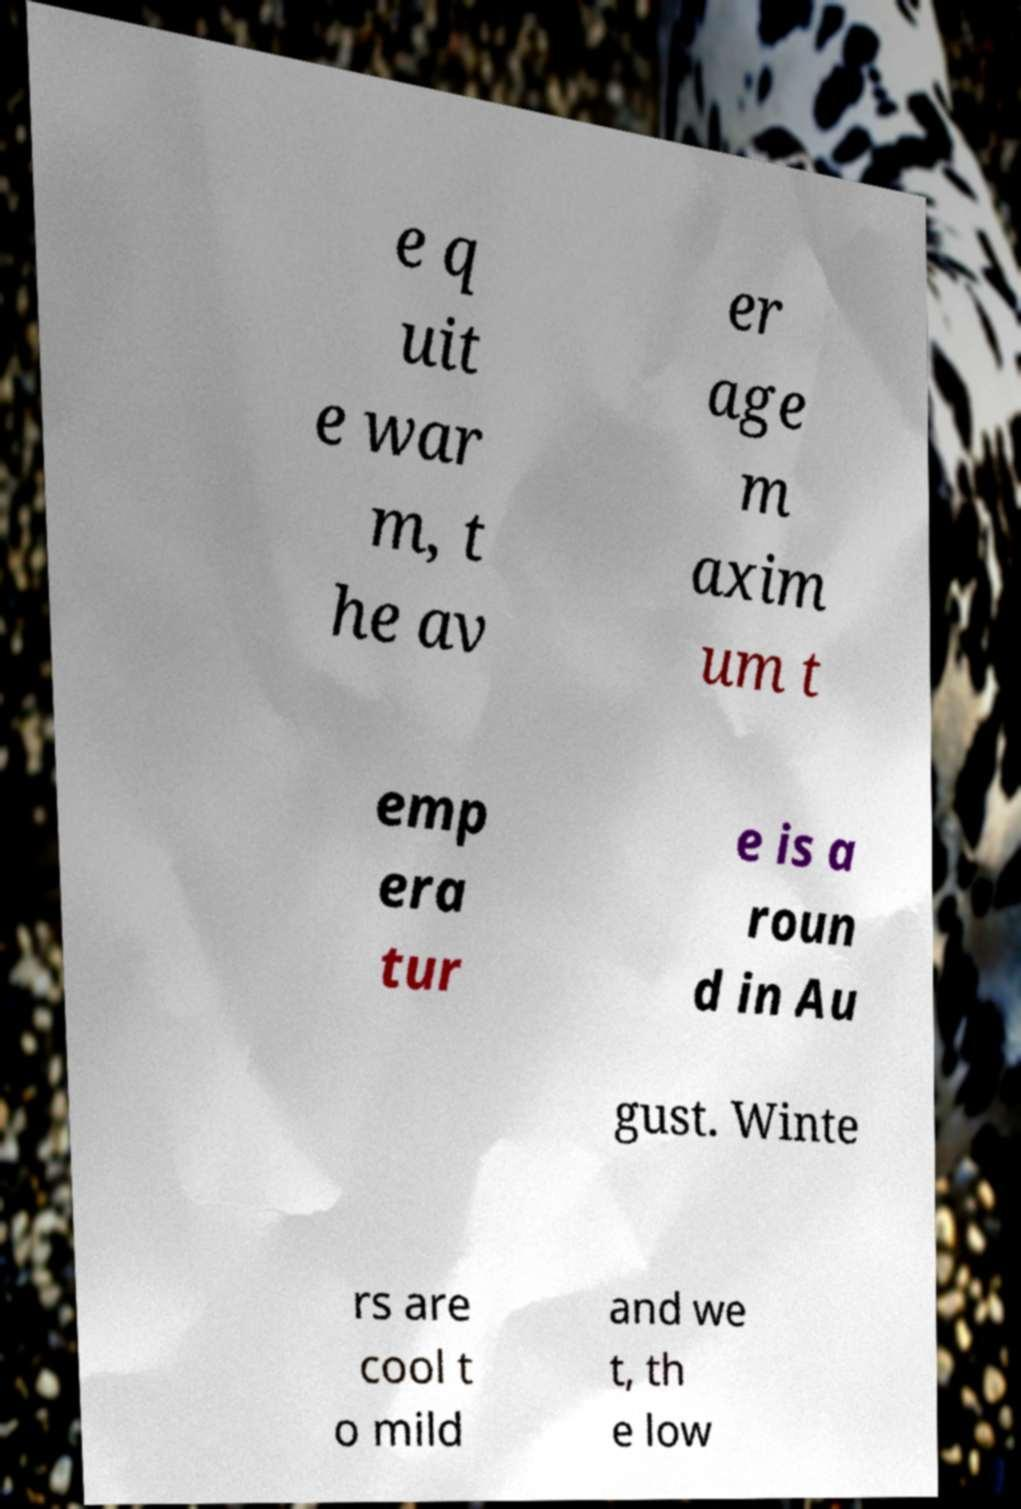Could you assist in decoding the text presented in this image and type it out clearly? e q uit e war m, t he av er age m axim um t emp era tur e is a roun d in Au gust. Winte rs are cool t o mild and we t, th e low 